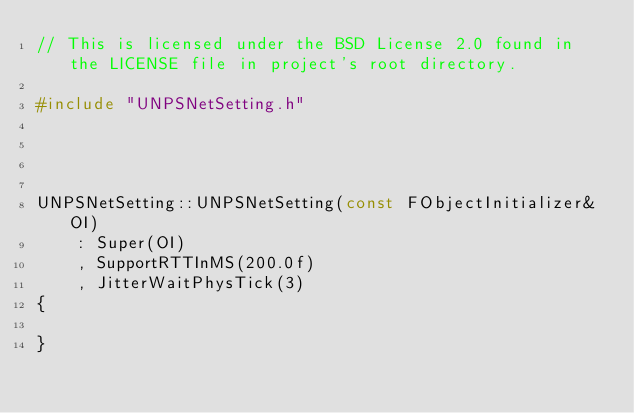Convert code to text. <code><loc_0><loc_0><loc_500><loc_500><_C++_>// This is licensed under the BSD License 2.0 found in the LICENSE file in project's root directory.

#include "UNPSNetSetting.h"




UNPSNetSetting::UNPSNetSetting(const FObjectInitializer& OI)
	: Super(OI)
	, SupportRTTInMS(200.0f)
	, JitterWaitPhysTick(3)
{

}
</code> 